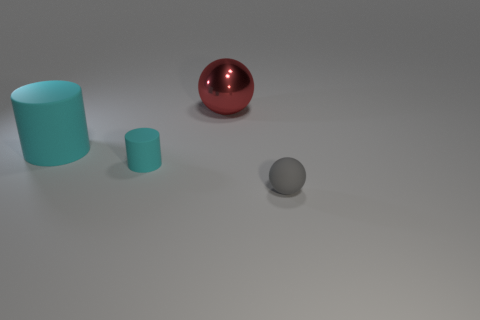What is the material of the object that is both in front of the red object and behind the tiny cyan matte object? The object in question appears to be a grey matte rubber ball, which is positioned in front of the larger glossy red sphere and behind the small cyan cylinder. 